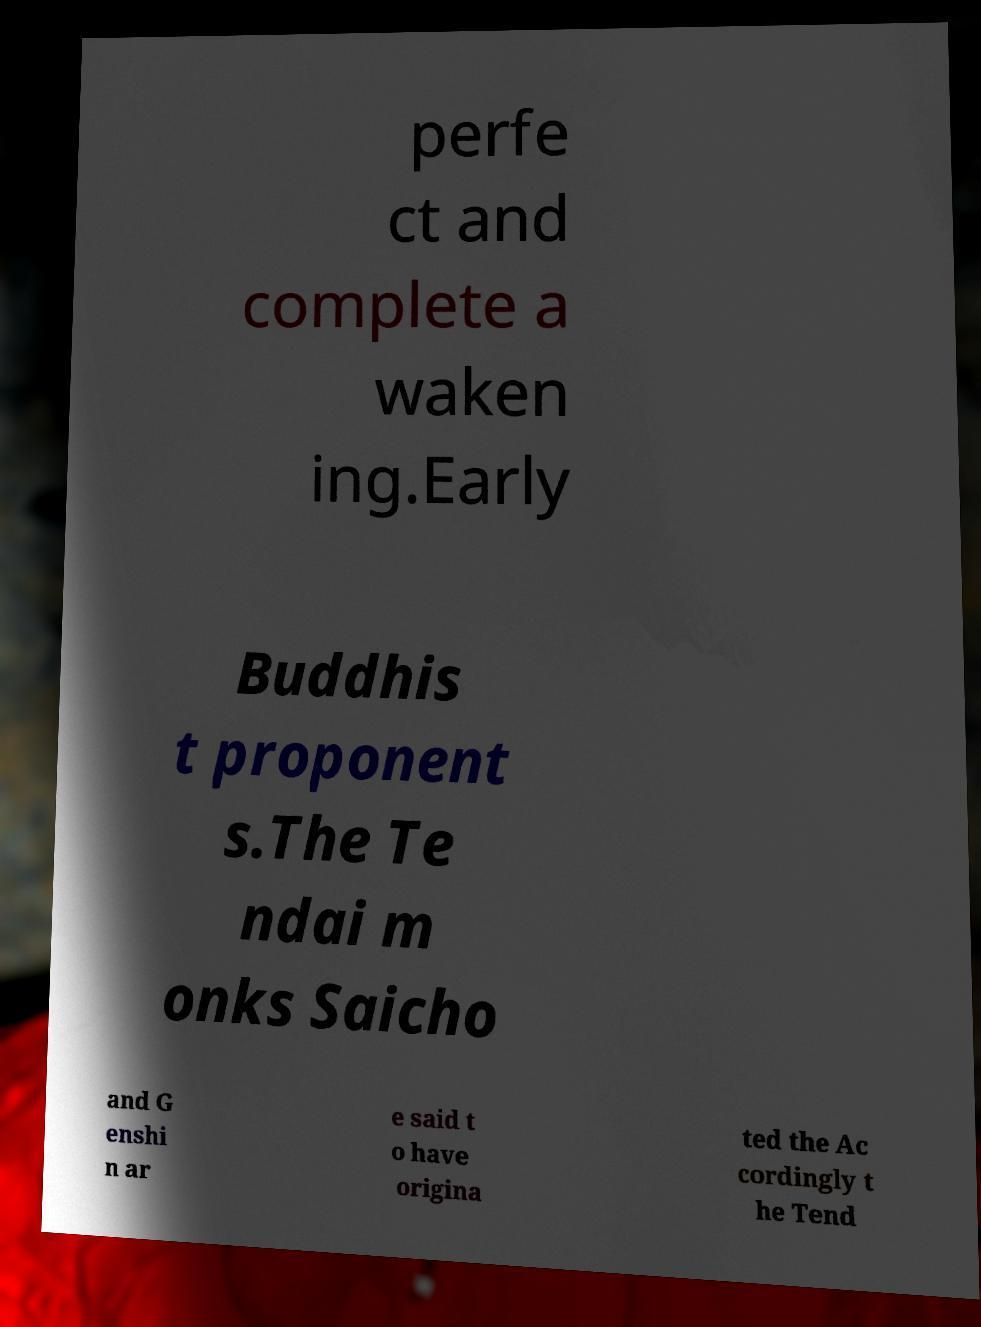Please identify and transcribe the text found in this image. perfe ct and complete a waken ing.Early Buddhis t proponent s.The Te ndai m onks Saicho and G enshi n ar e said t o have origina ted the Ac cordingly t he Tend 